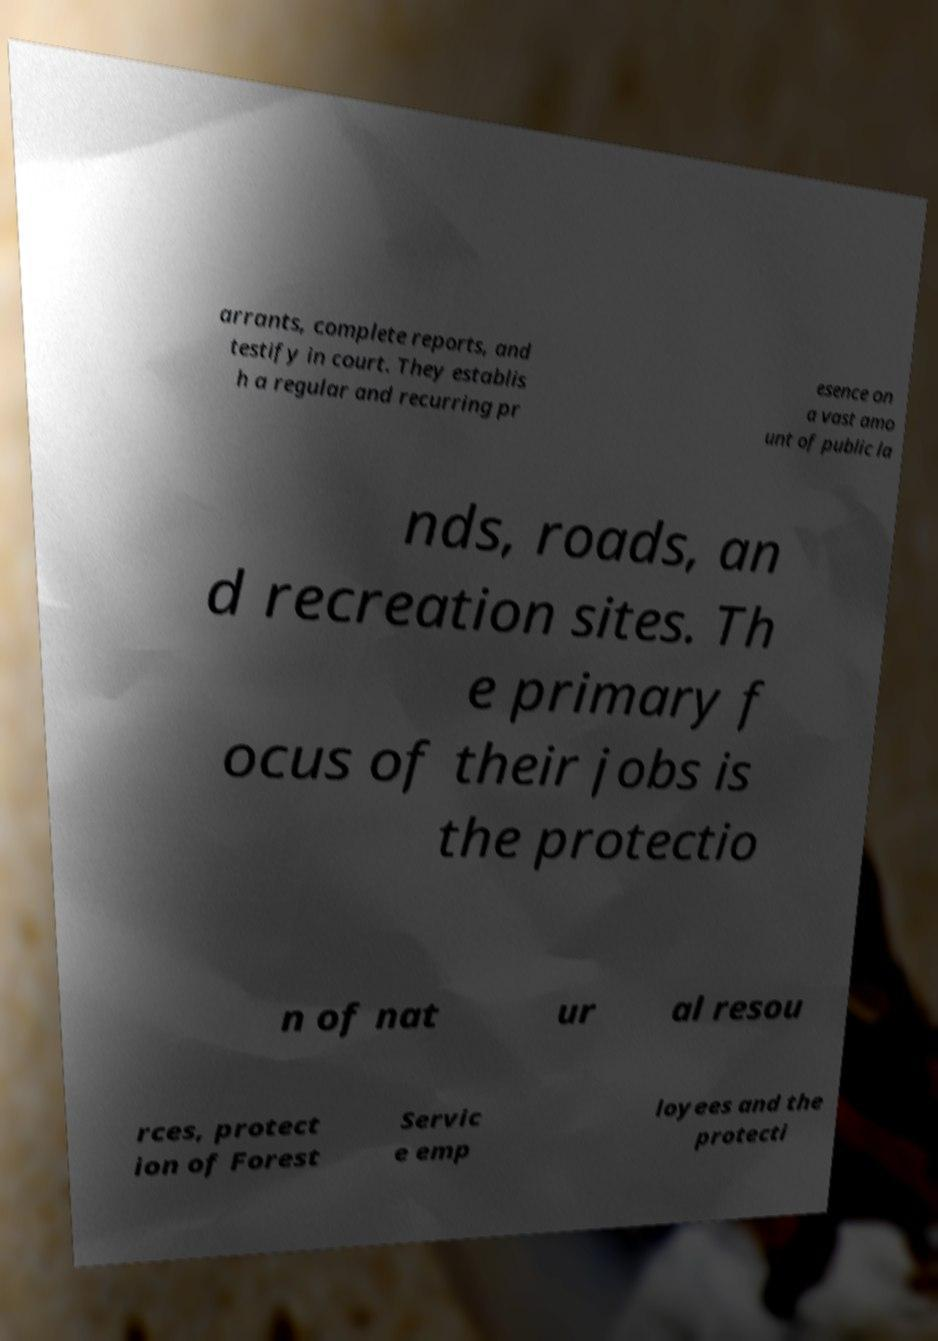Can you read and provide the text displayed in the image?This photo seems to have some interesting text. Can you extract and type it out for me? arrants, complete reports, and testify in court. They establis h a regular and recurring pr esence on a vast amo unt of public la nds, roads, an d recreation sites. Th e primary f ocus of their jobs is the protectio n of nat ur al resou rces, protect ion of Forest Servic e emp loyees and the protecti 